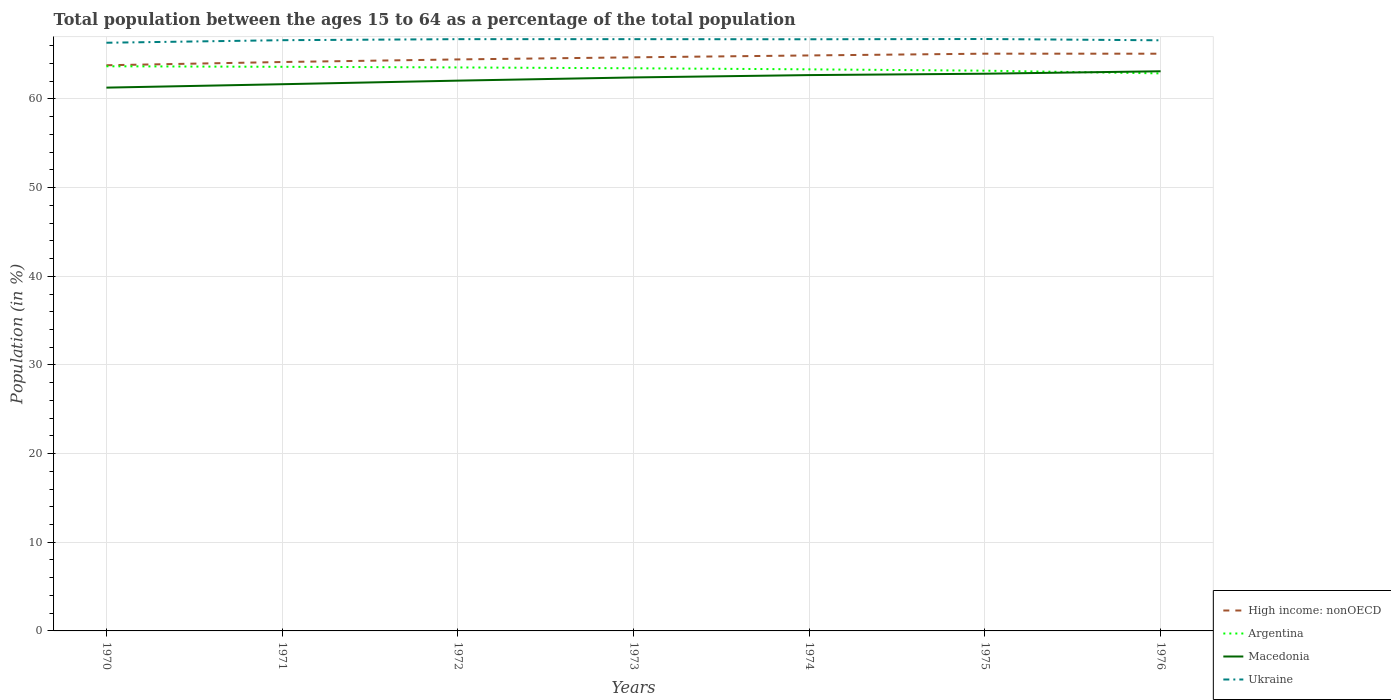Is the number of lines equal to the number of legend labels?
Your response must be concise. Yes. Across all years, what is the maximum percentage of the population ages 15 to 64 in Ukraine?
Provide a succinct answer. 66.34. In which year was the percentage of the population ages 15 to 64 in Argentina maximum?
Your answer should be very brief. 1976. What is the total percentage of the population ages 15 to 64 in Macedonia in the graph?
Provide a succinct answer. -0.63. What is the difference between the highest and the second highest percentage of the population ages 15 to 64 in Argentina?
Offer a very short reply. 0.8. How many years are there in the graph?
Keep it short and to the point. 7. Does the graph contain any zero values?
Offer a very short reply. No. How many legend labels are there?
Your answer should be very brief. 4. How are the legend labels stacked?
Provide a succinct answer. Vertical. What is the title of the graph?
Your answer should be very brief. Total population between the ages 15 to 64 as a percentage of the total population. Does "French Polynesia" appear as one of the legend labels in the graph?
Offer a very short reply. No. What is the label or title of the X-axis?
Provide a short and direct response. Years. What is the label or title of the Y-axis?
Offer a terse response. Population (in %). What is the Population (in %) in High income: nonOECD in 1970?
Offer a terse response. 63.8. What is the Population (in %) of Argentina in 1970?
Your response must be concise. 63.69. What is the Population (in %) in Macedonia in 1970?
Make the answer very short. 61.28. What is the Population (in %) of Ukraine in 1970?
Your answer should be very brief. 66.34. What is the Population (in %) in High income: nonOECD in 1971?
Your answer should be compact. 64.17. What is the Population (in %) of Argentina in 1971?
Your answer should be compact. 63.63. What is the Population (in %) of Macedonia in 1971?
Provide a succinct answer. 61.66. What is the Population (in %) in Ukraine in 1971?
Offer a very short reply. 66.63. What is the Population (in %) in High income: nonOECD in 1972?
Offer a very short reply. 64.46. What is the Population (in %) of Argentina in 1972?
Your answer should be compact. 63.55. What is the Population (in %) of Macedonia in 1972?
Your response must be concise. 62.07. What is the Population (in %) in Ukraine in 1972?
Your response must be concise. 66.74. What is the Population (in %) of High income: nonOECD in 1973?
Make the answer very short. 64.69. What is the Population (in %) of Argentina in 1973?
Ensure brevity in your answer.  63.46. What is the Population (in %) in Macedonia in 1973?
Ensure brevity in your answer.  62.43. What is the Population (in %) of Ukraine in 1973?
Keep it short and to the point. 66.74. What is the Population (in %) in High income: nonOECD in 1974?
Give a very brief answer. 64.91. What is the Population (in %) of Argentina in 1974?
Make the answer very short. 63.34. What is the Population (in %) in Macedonia in 1974?
Give a very brief answer. 62.69. What is the Population (in %) of Ukraine in 1974?
Make the answer very short. 66.73. What is the Population (in %) of High income: nonOECD in 1975?
Your answer should be very brief. 65.11. What is the Population (in %) in Argentina in 1975?
Make the answer very short. 63.19. What is the Population (in %) in Macedonia in 1975?
Provide a succinct answer. 62.85. What is the Population (in %) of Ukraine in 1975?
Make the answer very short. 66.76. What is the Population (in %) of High income: nonOECD in 1976?
Ensure brevity in your answer.  65.1. What is the Population (in %) of Argentina in 1976?
Offer a terse response. 62.88. What is the Population (in %) in Macedonia in 1976?
Ensure brevity in your answer.  63.12. What is the Population (in %) of Ukraine in 1976?
Provide a short and direct response. 66.62. Across all years, what is the maximum Population (in %) of High income: nonOECD?
Your answer should be very brief. 65.11. Across all years, what is the maximum Population (in %) of Argentina?
Keep it short and to the point. 63.69. Across all years, what is the maximum Population (in %) in Macedonia?
Give a very brief answer. 63.12. Across all years, what is the maximum Population (in %) of Ukraine?
Offer a terse response. 66.76. Across all years, what is the minimum Population (in %) of High income: nonOECD?
Ensure brevity in your answer.  63.8. Across all years, what is the minimum Population (in %) in Argentina?
Give a very brief answer. 62.88. Across all years, what is the minimum Population (in %) in Macedonia?
Offer a very short reply. 61.28. Across all years, what is the minimum Population (in %) of Ukraine?
Ensure brevity in your answer.  66.34. What is the total Population (in %) of High income: nonOECD in the graph?
Keep it short and to the point. 452.24. What is the total Population (in %) of Argentina in the graph?
Your answer should be very brief. 443.74. What is the total Population (in %) in Macedonia in the graph?
Your response must be concise. 436.09. What is the total Population (in %) in Ukraine in the graph?
Keep it short and to the point. 466.57. What is the difference between the Population (in %) in High income: nonOECD in 1970 and that in 1971?
Make the answer very short. -0.37. What is the difference between the Population (in %) of Argentina in 1970 and that in 1971?
Your response must be concise. 0.06. What is the difference between the Population (in %) of Macedonia in 1970 and that in 1971?
Your answer should be very brief. -0.38. What is the difference between the Population (in %) of Ukraine in 1970 and that in 1971?
Your answer should be compact. -0.29. What is the difference between the Population (in %) of High income: nonOECD in 1970 and that in 1972?
Provide a succinct answer. -0.66. What is the difference between the Population (in %) of Argentina in 1970 and that in 1972?
Offer a terse response. 0.13. What is the difference between the Population (in %) in Macedonia in 1970 and that in 1972?
Provide a short and direct response. -0.79. What is the difference between the Population (in %) in Ukraine in 1970 and that in 1972?
Provide a succinct answer. -0.4. What is the difference between the Population (in %) of High income: nonOECD in 1970 and that in 1973?
Make the answer very short. -0.89. What is the difference between the Population (in %) in Argentina in 1970 and that in 1973?
Ensure brevity in your answer.  0.23. What is the difference between the Population (in %) of Macedonia in 1970 and that in 1973?
Offer a terse response. -1.15. What is the difference between the Population (in %) of Ukraine in 1970 and that in 1973?
Provide a short and direct response. -0.4. What is the difference between the Population (in %) in High income: nonOECD in 1970 and that in 1974?
Provide a short and direct response. -1.11. What is the difference between the Population (in %) of Argentina in 1970 and that in 1974?
Your answer should be compact. 0.34. What is the difference between the Population (in %) in Macedonia in 1970 and that in 1974?
Provide a short and direct response. -1.41. What is the difference between the Population (in %) of Ukraine in 1970 and that in 1974?
Your answer should be very brief. -0.39. What is the difference between the Population (in %) of High income: nonOECD in 1970 and that in 1975?
Offer a very short reply. -1.31. What is the difference between the Population (in %) of Argentina in 1970 and that in 1975?
Keep it short and to the point. 0.5. What is the difference between the Population (in %) in Macedonia in 1970 and that in 1975?
Ensure brevity in your answer.  -1.57. What is the difference between the Population (in %) of Ukraine in 1970 and that in 1975?
Make the answer very short. -0.42. What is the difference between the Population (in %) in High income: nonOECD in 1970 and that in 1976?
Ensure brevity in your answer.  -1.3. What is the difference between the Population (in %) of Argentina in 1970 and that in 1976?
Your answer should be compact. 0.8. What is the difference between the Population (in %) of Macedonia in 1970 and that in 1976?
Offer a terse response. -1.85. What is the difference between the Population (in %) of Ukraine in 1970 and that in 1976?
Give a very brief answer. -0.28. What is the difference between the Population (in %) in High income: nonOECD in 1971 and that in 1972?
Your response must be concise. -0.29. What is the difference between the Population (in %) of Argentina in 1971 and that in 1972?
Provide a succinct answer. 0.07. What is the difference between the Population (in %) of Macedonia in 1971 and that in 1972?
Provide a succinct answer. -0.4. What is the difference between the Population (in %) in Ukraine in 1971 and that in 1972?
Offer a terse response. -0.12. What is the difference between the Population (in %) of High income: nonOECD in 1971 and that in 1973?
Make the answer very short. -0.53. What is the difference between the Population (in %) of Argentina in 1971 and that in 1973?
Your answer should be compact. 0.17. What is the difference between the Population (in %) in Macedonia in 1971 and that in 1973?
Offer a very short reply. -0.77. What is the difference between the Population (in %) of Ukraine in 1971 and that in 1973?
Your response must be concise. -0.12. What is the difference between the Population (in %) in High income: nonOECD in 1971 and that in 1974?
Provide a short and direct response. -0.74. What is the difference between the Population (in %) in Argentina in 1971 and that in 1974?
Your response must be concise. 0.29. What is the difference between the Population (in %) in Macedonia in 1971 and that in 1974?
Provide a succinct answer. -1.03. What is the difference between the Population (in %) in Ukraine in 1971 and that in 1974?
Your answer should be very brief. -0.1. What is the difference between the Population (in %) of High income: nonOECD in 1971 and that in 1975?
Keep it short and to the point. -0.94. What is the difference between the Population (in %) of Argentina in 1971 and that in 1975?
Your answer should be compact. 0.44. What is the difference between the Population (in %) in Macedonia in 1971 and that in 1975?
Provide a short and direct response. -1.19. What is the difference between the Population (in %) of Ukraine in 1971 and that in 1975?
Your answer should be compact. -0.13. What is the difference between the Population (in %) in High income: nonOECD in 1971 and that in 1976?
Offer a terse response. -0.94. What is the difference between the Population (in %) of Argentina in 1971 and that in 1976?
Make the answer very short. 0.75. What is the difference between the Population (in %) in Macedonia in 1971 and that in 1976?
Provide a succinct answer. -1.46. What is the difference between the Population (in %) of Ukraine in 1971 and that in 1976?
Keep it short and to the point. 0.01. What is the difference between the Population (in %) of High income: nonOECD in 1972 and that in 1973?
Your answer should be compact. -0.24. What is the difference between the Population (in %) of Argentina in 1972 and that in 1973?
Provide a succinct answer. 0.09. What is the difference between the Population (in %) of Macedonia in 1972 and that in 1973?
Ensure brevity in your answer.  -0.36. What is the difference between the Population (in %) of Ukraine in 1972 and that in 1973?
Offer a terse response. -0. What is the difference between the Population (in %) of High income: nonOECD in 1972 and that in 1974?
Give a very brief answer. -0.45. What is the difference between the Population (in %) of Argentina in 1972 and that in 1974?
Your answer should be compact. 0.21. What is the difference between the Population (in %) in Macedonia in 1972 and that in 1974?
Provide a succinct answer. -0.63. What is the difference between the Population (in %) in Ukraine in 1972 and that in 1974?
Offer a terse response. 0.01. What is the difference between the Population (in %) in High income: nonOECD in 1972 and that in 1975?
Provide a succinct answer. -0.65. What is the difference between the Population (in %) in Argentina in 1972 and that in 1975?
Ensure brevity in your answer.  0.36. What is the difference between the Population (in %) in Macedonia in 1972 and that in 1975?
Your answer should be compact. -0.78. What is the difference between the Population (in %) in Ukraine in 1972 and that in 1975?
Offer a terse response. -0.02. What is the difference between the Population (in %) of High income: nonOECD in 1972 and that in 1976?
Ensure brevity in your answer.  -0.65. What is the difference between the Population (in %) of Argentina in 1972 and that in 1976?
Ensure brevity in your answer.  0.67. What is the difference between the Population (in %) of Macedonia in 1972 and that in 1976?
Offer a terse response. -1.06. What is the difference between the Population (in %) of Ukraine in 1972 and that in 1976?
Ensure brevity in your answer.  0.13. What is the difference between the Population (in %) of High income: nonOECD in 1973 and that in 1974?
Your answer should be very brief. -0.21. What is the difference between the Population (in %) in Argentina in 1973 and that in 1974?
Provide a short and direct response. 0.12. What is the difference between the Population (in %) in Macedonia in 1973 and that in 1974?
Offer a very short reply. -0.26. What is the difference between the Population (in %) in Ukraine in 1973 and that in 1974?
Offer a terse response. 0.01. What is the difference between the Population (in %) of High income: nonOECD in 1973 and that in 1975?
Your answer should be very brief. -0.41. What is the difference between the Population (in %) in Argentina in 1973 and that in 1975?
Make the answer very short. 0.27. What is the difference between the Population (in %) of Macedonia in 1973 and that in 1975?
Your answer should be very brief. -0.42. What is the difference between the Population (in %) of Ukraine in 1973 and that in 1975?
Offer a very short reply. -0.02. What is the difference between the Population (in %) of High income: nonOECD in 1973 and that in 1976?
Your response must be concise. -0.41. What is the difference between the Population (in %) of Argentina in 1973 and that in 1976?
Provide a succinct answer. 0.58. What is the difference between the Population (in %) in Macedonia in 1973 and that in 1976?
Keep it short and to the point. -0.7. What is the difference between the Population (in %) in Ukraine in 1973 and that in 1976?
Your answer should be compact. 0.13. What is the difference between the Population (in %) of High income: nonOECD in 1974 and that in 1975?
Your response must be concise. -0.2. What is the difference between the Population (in %) in Argentina in 1974 and that in 1975?
Offer a terse response. 0.15. What is the difference between the Population (in %) of Macedonia in 1974 and that in 1975?
Offer a very short reply. -0.16. What is the difference between the Population (in %) in Ukraine in 1974 and that in 1975?
Your answer should be very brief. -0.03. What is the difference between the Population (in %) in High income: nonOECD in 1974 and that in 1976?
Your answer should be very brief. -0.2. What is the difference between the Population (in %) in Argentina in 1974 and that in 1976?
Offer a terse response. 0.46. What is the difference between the Population (in %) of Macedonia in 1974 and that in 1976?
Make the answer very short. -0.43. What is the difference between the Population (in %) of Ukraine in 1974 and that in 1976?
Offer a very short reply. 0.12. What is the difference between the Population (in %) in High income: nonOECD in 1975 and that in 1976?
Ensure brevity in your answer.  0. What is the difference between the Population (in %) in Argentina in 1975 and that in 1976?
Provide a succinct answer. 0.31. What is the difference between the Population (in %) of Macedonia in 1975 and that in 1976?
Your answer should be compact. -0.28. What is the difference between the Population (in %) of Ukraine in 1975 and that in 1976?
Provide a succinct answer. 0.15. What is the difference between the Population (in %) in High income: nonOECD in 1970 and the Population (in %) in Argentina in 1971?
Offer a very short reply. 0.17. What is the difference between the Population (in %) in High income: nonOECD in 1970 and the Population (in %) in Macedonia in 1971?
Give a very brief answer. 2.14. What is the difference between the Population (in %) in High income: nonOECD in 1970 and the Population (in %) in Ukraine in 1971?
Your answer should be compact. -2.83. What is the difference between the Population (in %) of Argentina in 1970 and the Population (in %) of Macedonia in 1971?
Keep it short and to the point. 2.02. What is the difference between the Population (in %) of Argentina in 1970 and the Population (in %) of Ukraine in 1971?
Provide a succinct answer. -2.94. What is the difference between the Population (in %) in Macedonia in 1970 and the Population (in %) in Ukraine in 1971?
Your response must be concise. -5.35. What is the difference between the Population (in %) in High income: nonOECD in 1970 and the Population (in %) in Argentina in 1972?
Your answer should be very brief. 0.25. What is the difference between the Population (in %) in High income: nonOECD in 1970 and the Population (in %) in Macedonia in 1972?
Provide a short and direct response. 1.74. What is the difference between the Population (in %) of High income: nonOECD in 1970 and the Population (in %) of Ukraine in 1972?
Your response must be concise. -2.94. What is the difference between the Population (in %) of Argentina in 1970 and the Population (in %) of Macedonia in 1972?
Give a very brief answer. 1.62. What is the difference between the Population (in %) of Argentina in 1970 and the Population (in %) of Ukraine in 1972?
Provide a short and direct response. -3.06. What is the difference between the Population (in %) of Macedonia in 1970 and the Population (in %) of Ukraine in 1972?
Offer a very short reply. -5.47. What is the difference between the Population (in %) in High income: nonOECD in 1970 and the Population (in %) in Argentina in 1973?
Ensure brevity in your answer.  0.34. What is the difference between the Population (in %) in High income: nonOECD in 1970 and the Population (in %) in Macedonia in 1973?
Provide a short and direct response. 1.37. What is the difference between the Population (in %) of High income: nonOECD in 1970 and the Population (in %) of Ukraine in 1973?
Your answer should be compact. -2.94. What is the difference between the Population (in %) in Argentina in 1970 and the Population (in %) in Macedonia in 1973?
Your answer should be very brief. 1.26. What is the difference between the Population (in %) of Argentina in 1970 and the Population (in %) of Ukraine in 1973?
Offer a terse response. -3.06. What is the difference between the Population (in %) in Macedonia in 1970 and the Population (in %) in Ukraine in 1973?
Offer a terse response. -5.47. What is the difference between the Population (in %) in High income: nonOECD in 1970 and the Population (in %) in Argentina in 1974?
Ensure brevity in your answer.  0.46. What is the difference between the Population (in %) of High income: nonOECD in 1970 and the Population (in %) of Macedonia in 1974?
Offer a terse response. 1.11. What is the difference between the Population (in %) in High income: nonOECD in 1970 and the Population (in %) in Ukraine in 1974?
Provide a short and direct response. -2.93. What is the difference between the Population (in %) in Argentina in 1970 and the Population (in %) in Ukraine in 1974?
Provide a succinct answer. -3.05. What is the difference between the Population (in %) of Macedonia in 1970 and the Population (in %) of Ukraine in 1974?
Ensure brevity in your answer.  -5.45. What is the difference between the Population (in %) in High income: nonOECD in 1970 and the Population (in %) in Argentina in 1975?
Make the answer very short. 0.61. What is the difference between the Population (in %) of High income: nonOECD in 1970 and the Population (in %) of Macedonia in 1975?
Offer a very short reply. 0.95. What is the difference between the Population (in %) of High income: nonOECD in 1970 and the Population (in %) of Ukraine in 1975?
Offer a very short reply. -2.96. What is the difference between the Population (in %) in Argentina in 1970 and the Population (in %) in Macedonia in 1975?
Give a very brief answer. 0.84. What is the difference between the Population (in %) of Argentina in 1970 and the Population (in %) of Ukraine in 1975?
Provide a succinct answer. -3.08. What is the difference between the Population (in %) of Macedonia in 1970 and the Population (in %) of Ukraine in 1975?
Your answer should be very brief. -5.48. What is the difference between the Population (in %) of High income: nonOECD in 1970 and the Population (in %) of Argentina in 1976?
Provide a short and direct response. 0.92. What is the difference between the Population (in %) of High income: nonOECD in 1970 and the Population (in %) of Macedonia in 1976?
Keep it short and to the point. 0.68. What is the difference between the Population (in %) in High income: nonOECD in 1970 and the Population (in %) in Ukraine in 1976?
Ensure brevity in your answer.  -2.82. What is the difference between the Population (in %) in Argentina in 1970 and the Population (in %) in Macedonia in 1976?
Provide a succinct answer. 0.56. What is the difference between the Population (in %) of Argentina in 1970 and the Population (in %) of Ukraine in 1976?
Give a very brief answer. -2.93. What is the difference between the Population (in %) in Macedonia in 1970 and the Population (in %) in Ukraine in 1976?
Provide a short and direct response. -5.34. What is the difference between the Population (in %) of High income: nonOECD in 1971 and the Population (in %) of Argentina in 1972?
Ensure brevity in your answer.  0.61. What is the difference between the Population (in %) of High income: nonOECD in 1971 and the Population (in %) of Macedonia in 1972?
Ensure brevity in your answer.  2.1. What is the difference between the Population (in %) of High income: nonOECD in 1971 and the Population (in %) of Ukraine in 1972?
Provide a short and direct response. -2.58. What is the difference between the Population (in %) in Argentina in 1971 and the Population (in %) in Macedonia in 1972?
Ensure brevity in your answer.  1.56. What is the difference between the Population (in %) in Argentina in 1971 and the Population (in %) in Ukraine in 1972?
Provide a short and direct response. -3.12. What is the difference between the Population (in %) in Macedonia in 1971 and the Population (in %) in Ukraine in 1972?
Make the answer very short. -5.08. What is the difference between the Population (in %) in High income: nonOECD in 1971 and the Population (in %) in Argentina in 1973?
Offer a very short reply. 0.71. What is the difference between the Population (in %) of High income: nonOECD in 1971 and the Population (in %) of Macedonia in 1973?
Offer a very short reply. 1.74. What is the difference between the Population (in %) of High income: nonOECD in 1971 and the Population (in %) of Ukraine in 1973?
Ensure brevity in your answer.  -2.58. What is the difference between the Population (in %) in Argentina in 1971 and the Population (in %) in Macedonia in 1973?
Keep it short and to the point. 1.2. What is the difference between the Population (in %) of Argentina in 1971 and the Population (in %) of Ukraine in 1973?
Ensure brevity in your answer.  -3.12. What is the difference between the Population (in %) of Macedonia in 1971 and the Population (in %) of Ukraine in 1973?
Give a very brief answer. -5.08. What is the difference between the Population (in %) in High income: nonOECD in 1971 and the Population (in %) in Argentina in 1974?
Give a very brief answer. 0.83. What is the difference between the Population (in %) of High income: nonOECD in 1971 and the Population (in %) of Macedonia in 1974?
Your answer should be compact. 1.48. What is the difference between the Population (in %) in High income: nonOECD in 1971 and the Population (in %) in Ukraine in 1974?
Offer a very short reply. -2.57. What is the difference between the Population (in %) in Argentina in 1971 and the Population (in %) in Ukraine in 1974?
Your answer should be very brief. -3.1. What is the difference between the Population (in %) in Macedonia in 1971 and the Population (in %) in Ukraine in 1974?
Your answer should be very brief. -5.07. What is the difference between the Population (in %) of High income: nonOECD in 1971 and the Population (in %) of Argentina in 1975?
Offer a terse response. 0.98. What is the difference between the Population (in %) of High income: nonOECD in 1971 and the Population (in %) of Macedonia in 1975?
Your answer should be very brief. 1.32. What is the difference between the Population (in %) in High income: nonOECD in 1971 and the Population (in %) in Ukraine in 1975?
Your response must be concise. -2.59. What is the difference between the Population (in %) in Argentina in 1971 and the Population (in %) in Macedonia in 1975?
Keep it short and to the point. 0.78. What is the difference between the Population (in %) in Argentina in 1971 and the Population (in %) in Ukraine in 1975?
Ensure brevity in your answer.  -3.13. What is the difference between the Population (in %) in High income: nonOECD in 1971 and the Population (in %) in Argentina in 1976?
Give a very brief answer. 1.28. What is the difference between the Population (in %) in High income: nonOECD in 1971 and the Population (in %) in Macedonia in 1976?
Provide a short and direct response. 1.04. What is the difference between the Population (in %) in High income: nonOECD in 1971 and the Population (in %) in Ukraine in 1976?
Ensure brevity in your answer.  -2.45. What is the difference between the Population (in %) of Argentina in 1971 and the Population (in %) of Macedonia in 1976?
Keep it short and to the point. 0.51. What is the difference between the Population (in %) of Argentina in 1971 and the Population (in %) of Ukraine in 1976?
Keep it short and to the point. -2.99. What is the difference between the Population (in %) in Macedonia in 1971 and the Population (in %) in Ukraine in 1976?
Keep it short and to the point. -4.95. What is the difference between the Population (in %) of High income: nonOECD in 1972 and the Population (in %) of Macedonia in 1973?
Ensure brevity in your answer.  2.03. What is the difference between the Population (in %) of High income: nonOECD in 1972 and the Population (in %) of Ukraine in 1973?
Your answer should be very brief. -2.29. What is the difference between the Population (in %) of Argentina in 1972 and the Population (in %) of Macedonia in 1973?
Your response must be concise. 1.13. What is the difference between the Population (in %) in Argentina in 1972 and the Population (in %) in Ukraine in 1973?
Your answer should be compact. -3.19. What is the difference between the Population (in %) of Macedonia in 1972 and the Population (in %) of Ukraine in 1973?
Your answer should be compact. -4.68. What is the difference between the Population (in %) of High income: nonOECD in 1972 and the Population (in %) of Argentina in 1974?
Give a very brief answer. 1.12. What is the difference between the Population (in %) of High income: nonOECD in 1972 and the Population (in %) of Macedonia in 1974?
Offer a terse response. 1.77. What is the difference between the Population (in %) of High income: nonOECD in 1972 and the Population (in %) of Ukraine in 1974?
Provide a succinct answer. -2.27. What is the difference between the Population (in %) of Argentina in 1972 and the Population (in %) of Macedonia in 1974?
Give a very brief answer. 0.86. What is the difference between the Population (in %) of Argentina in 1972 and the Population (in %) of Ukraine in 1974?
Offer a very short reply. -3.18. What is the difference between the Population (in %) of Macedonia in 1972 and the Population (in %) of Ukraine in 1974?
Make the answer very short. -4.67. What is the difference between the Population (in %) in High income: nonOECD in 1972 and the Population (in %) in Argentina in 1975?
Offer a very short reply. 1.27. What is the difference between the Population (in %) in High income: nonOECD in 1972 and the Population (in %) in Macedonia in 1975?
Provide a short and direct response. 1.61. What is the difference between the Population (in %) in High income: nonOECD in 1972 and the Population (in %) in Ukraine in 1975?
Keep it short and to the point. -2.3. What is the difference between the Population (in %) in Argentina in 1972 and the Population (in %) in Macedonia in 1975?
Your answer should be very brief. 0.71. What is the difference between the Population (in %) of Argentina in 1972 and the Population (in %) of Ukraine in 1975?
Ensure brevity in your answer.  -3.21. What is the difference between the Population (in %) of Macedonia in 1972 and the Population (in %) of Ukraine in 1975?
Ensure brevity in your answer.  -4.7. What is the difference between the Population (in %) in High income: nonOECD in 1972 and the Population (in %) in Argentina in 1976?
Offer a terse response. 1.58. What is the difference between the Population (in %) in High income: nonOECD in 1972 and the Population (in %) in Macedonia in 1976?
Your answer should be very brief. 1.34. What is the difference between the Population (in %) in High income: nonOECD in 1972 and the Population (in %) in Ukraine in 1976?
Provide a succinct answer. -2.16. What is the difference between the Population (in %) of Argentina in 1972 and the Population (in %) of Macedonia in 1976?
Provide a short and direct response. 0.43. What is the difference between the Population (in %) in Argentina in 1972 and the Population (in %) in Ukraine in 1976?
Offer a very short reply. -3.06. What is the difference between the Population (in %) in Macedonia in 1972 and the Population (in %) in Ukraine in 1976?
Keep it short and to the point. -4.55. What is the difference between the Population (in %) of High income: nonOECD in 1973 and the Population (in %) of Argentina in 1974?
Keep it short and to the point. 1.35. What is the difference between the Population (in %) of High income: nonOECD in 1973 and the Population (in %) of Macedonia in 1974?
Give a very brief answer. 2. What is the difference between the Population (in %) of High income: nonOECD in 1973 and the Population (in %) of Ukraine in 1974?
Give a very brief answer. -2.04. What is the difference between the Population (in %) in Argentina in 1973 and the Population (in %) in Macedonia in 1974?
Offer a terse response. 0.77. What is the difference between the Population (in %) in Argentina in 1973 and the Population (in %) in Ukraine in 1974?
Give a very brief answer. -3.27. What is the difference between the Population (in %) of Macedonia in 1973 and the Population (in %) of Ukraine in 1974?
Keep it short and to the point. -4.31. What is the difference between the Population (in %) in High income: nonOECD in 1973 and the Population (in %) in Argentina in 1975?
Offer a very short reply. 1.51. What is the difference between the Population (in %) in High income: nonOECD in 1973 and the Population (in %) in Macedonia in 1975?
Offer a terse response. 1.85. What is the difference between the Population (in %) in High income: nonOECD in 1973 and the Population (in %) in Ukraine in 1975?
Your response must be concise. -2.07. What is the difference between the Population (in %) of Argentina in 1973 and the Population (in %) of Macedonia in 1975?
Give a very brief answer. 0.61. What is the difference between the Population (in %) of Argentina in 1973 and the Population (in %) of Ukraine in 1975?
Ensure brevity in your answer.  -3.3. What is the difference between the Population (in %) in Macedonia in 1973 and the Population (in %) in Ukraine in 1975?
Your answer should be compact. -4.33. What is the difference between the Population (in %) in High income: nonOECD in 1973 and the Population (in %) in Argentina in 1976?
Ensure brevity in your answer.  1.81. What is the difference between the Population (in %) of High income: nonOECD in 1973 and the Population (in %) of Macedonia in 1976?
Give a very brief answer. 1.57. What is the difference between the Population (in %) of High income: nonOECD in 1973 and the Population (in %) of Ukraine in 1976?
Offer a very short reply. -1.92. What is the difference between the Population (in %) of Argentina in 1973 and the Population (in %) of Macedonia in 1976?
Offer a very short reply. 0.34. What is the difference between the Population (in %) of Argentina in 1973 and the Population (in %) of Ukraine in 1976?
Make the answer very short. -3.16. What is the difference between the Population (in %) of Macedonia in 1973 and the Population (in %) of Ukraine in 1976?
Your response must be concise. -4.19. What is the difference between the Population (in %) in High income: nonOECD in 1974 and the Population (in %) in Argentina in 1975?
Keep it short and to the point. 1.72. What is the difference between the Population (in %) of High income: nonOECD in 1974 and the Population (in %) of Macedonia in 1975?
Offer a terse response. 2.06. What is the difference between the Population (in %) of High income: nonOECD in 1974 and the Population (in %) of Ukraine in 1975?
Offer a very short reply. -1.85. What is the difference between the Population (in %) in Argentina in 1974 and the Population (in %) in Macedonia in 1975?
Make the answer very short. 0.49. What is the difference between the Population (in %) of Argentina in 1974 and the Population (in %) of Ukraine in 1975?
Provide a succinct answer. -3.42. What is the difference between the Population (in %) of Macedonia in 1974 and the Population (in %) of Ukraine in 1975?
Provide a succinct answer. -4.07. What is the difference between the Population (in %) in High income: nonOECD in 1974 and the Population (in %) in Argentina in 1976?
Your answer should be very brief. 2.03. What is the difference between the Population (in %) in High income: nonOECD in 1974 and the Population (in %) in Macedonia in 1976?
Provide a succinct answer. 1.78. What is the difference between the Population (in %) of High income: nonOECD in 1974 and the Population (in %) of Ukraine in 1976?
Make the answer very short. -1.71. What is the difference between the Population (in %) in Argentina in 1974 and the Population (in %) in Macedonia in 1976?
Provide a succinct answer. 0.22. What is the difference between the Population (in %) of Argentina in 1974 and the Population (in %) of Ukraine in 1976?
Give a very brief answer. -3.27. What is the difference between the Population (in %) in Macedonia in 1974 and the Population (in %) in Ukraine in 1976?
Give a very brief answer. -3.92. What is the difference between the Population (in %) in High income: nonOECD in 1975 and the Population (in %) in Argentina in 1976?
Offer a very short reply. 2.22. What is the difference between the Population (in %) of High income: nonOECD in 1975 and the Population (in %) of Macedonia in 1976?
Provide a succinct answer. 1.98. What is the difference between the Population (in %) of High income: nonOECD in 1975 and the Population (in %) of Ukraine in 1976?
Ensure brevity in your answer.  -1.51. What is the difference between the Population (in %) in Argentina in 1975 and the Population (in %) in Macedonia in 1976?
Keep it short and to the point. 0.07. What is the difference between the Population (in %) of Argentina in 1975 and the Population (in %) of Ukraine in 1976?
Provide a succinct answer. -3.43. What is the difference between the Population (in %) in Macedonia in 1975 and the Population (in %) in Ukraine in 1976?
Your answer should be compact. -3.77. What is the average Population (in %) of High income: nonOECD per year?
Your answer should be very brief. 64.61. What is the average Population (in %) of Argentina per year?
Offer a very short reply. 63.39. What is the average Population (in %) of Macedonia per year?
Offer a terse response. 62.3. What is the average Population (in %) of Ukraine per year?
Ensure brevity in your answer.  66.65. In the year 1970, what is the difference between the Population (in %) of High income: nonOECD and Population (in %) of Argentina?
Provide a succinct answer. 0.11. In the year 1970, what is the difference between the Population (in %) in High income: nonOECD and Population (in %) in Macedonia?
Your answer should be compact. 2.52. In the year 1970, what is the difference between the Population (in %) of High income: nonOECD and Population (in %) of Ukraine?
Provide a short and direct response. -2.54. In the year 1970, what is the difference between the Population (in %) of Argentina and Population (in %) of Macedonia?
Make the answer very short. 2.41. In the year 1970, what is the difference between the Population (in %) of Argentina and Population (in %) of Ukraine?
Offer a very short reply. -2.65. In the year 1970, what is the difference between the Population (in %) in Macedonia and Population (in %) in Ukraine?
Provide a short and direct response. -5.06. In the year 1971, what is the difference between the Population (in %) in High income: nonOECD and Population (in %) in Argentina?
Your response must be concise. 0.54. In the year 1971, what is the difference between the Population (in %) of High income: nonOECD and Population (in %) of Macedonia?
Provide a short and direct response. 2.51. In the year 1971, what is the difference between the Population (in %) of High income: nonOECD and Population (in %) of Ukraine?
Make the answer very short. -2.46. In the year 1971, what is the difference between the Population (in %) of Argentina and Population (in %) of Macedonia?
Give a very brief answer. 1.97. In the year 1971, what is the difference between the Population (in %) of Argentina and Population (in %) of Ukraine?
Offer a very short reply. -3. In the year 1971, what is the difference between the Population (in %) in Macedonia and Population (in %) in Ukraine?
Provide a short and direct response. -4.97. In the year 1972, what is the difference between the Population (in %) of High income: nonOECD and Population (in %) of Argentina?
Offer a very short reply. 0.9. In the year 1972, what is the difference between the Population (in %) of High income: nonOECD and Population (in %) of Macedonia?
Offer a terse response. 2.39. In the year 1972, what is the difference between the Population (in %) of High income: nonOECD and Population (in %) of Ukraine?
Your answer should be compact. -2.29. In the year 1972, what is the difference between the Population (in %) of Argentina and Population (in %) of Macedonia?
Your answer should be compact. 1.49. In the year 1972, what is the difference between the Population (in %) in Argentina and Population (in %) in Ukraine?
Offer a terse response. -3.19. In the year 1972, what is the difference between the Population (in %) in Macedonia and Population (in %) in Ukraine?
Offer a very short reply. -4.68. In the year 1973, what is the difference between the Population (in %) of High income: nonOECD and Population (in %) of Argentina?
Your response must be concise. 1.23. In the year 1973, what is the difference between the Population (in %) of High income: nonOECD and Population (in %) of Macedonia?
Provide a short and direct response. 2.27. In the year 1973, what is the difference between the Population (in %) in High income: nonOECD and Population (in %) in Ukraine?
Give a very brief answer. -2.05. In the year 1973, what is the difference between the Population (in %) in Argentina and Population (in %) in Macedonia?
Your response must be concise. 1.03. In the year 1973, what is the difference between the Population (in %) in Argentina and Population (in %) in Ukraine?
Ensure brevity in your answer.  -3.28. In the year 1973, what is the difference between the Population (in %) in Macedonia and Population (in %) in Ukraine?
Provide a succinct answer. -4.32. In the year 1974, what is the difference between the Population (in %) of High income: nonOECD and Population (in %) of Argentina?
Your answer should be compact. 1.57. In the year 1974, what is the difference between the Population (in %) of High income: nonOECD and Population (in %) of Macedonia?
Offer a very short reply. 2.22. In the year 1974, what is the difference between the Population (in %) in High income: nonOECD and Population (in %) in Ukraine?
Make the answer very short. -1.82. In the year 1974, what is the difference between the Population (in %) in Argentina and Population (in %) in Macedonia?
Your response must be concise. 0.65. In the year 1974, what is the difference between the Population (in %) of Argentina and Population (in %) of Ukraine?
Provide a succinct answer. -3.39. In the year 1974, what is the difference between the Population (in %) in Macedonia and Population (in %) in Ukraine?
Your response must be concise. -4.04. In the year 1975, what is the difference between the Population (in %) of High income: nonOECD and Population (in %) of Argentina?
Keep it short and to the point. 1.92. In the year 1975, what is the difference between the Population (in %) of High income: nonOECD and Population (in %) of Macedonia?
Provide a succinct answer. 2.26. In the year 1975, what is the difference between the Population (in %) in High income: nonOECD and Population (in %) in Ukraine?
Keep it short and to the point. -1.66. In the year 1975, what is the difference between the Population (in %) in Argentina and Population (in %) in Macedonia?
Ensure brevity in your answer.  0.34. In the year 1975, what is the difference between the Population (in %) in Argentina and Population (in %) in Ukraine?
Make the answer very short. -3.57. In the year 1975, what is the difference between the Population (in %) of Macedonia and Population (in %) of Ukraine?
Keep it short and to the point. -3.91. In the year 1976, what is the difference between the Population (in %) in High income: nonOECD and Population (in %) in Argentina?
Make the answer very short. 2.22. In the year 1976, what is the difference between the Population (in %) in High income: nonOECD and Population (in %) in Macedonia?
Your response must be concise. 1.98. In the year 1976, what is the difference between the Population (in %) of High income: nonOECD and Population (in %) of Ukraine?
Provide a succinct answer. -1.51. In the year 1976, what is the difference between the Population (in %) in Argentina and Population (in %) in Macedonia?
Your response must be concise. -0.24. In the year 1976, what is the difference between the Population (in %) of Argentina and Population (in %) of Ukraine?
Give a very brief answer. -3.73. In the year 1976, what is the difference between the Population (in %) of Macedonia and Population (in %) of Ukraine?
Make the answer very short. -3.49. What is the ratio of the Population (in %) of High income: nonOECD in 1970 to that in 1971?
Provide a succinct answer. 0.99. What is the ratio of the Population (in %) in Argentina in 1970 to that in 1971?
Your answer should be compact. 1. What is the ratio of the Population (in %) of High income: nonOECD in 1970 to that in 1972?
Offer a very short reply. 0.99. What is the ratio of the Population (in %) of Macedonia in 1970 to that in 1972?
Ensure brevity in your answer.  0.99. What is the ratio of the Population (in %) of Ukraine in 1970 to that in 1972?
Give a very brief answer. 0.99. What is the ratio of the Population (in %) of High income: nonOECD in 1970 to that in 1973?
Provide a short and direct response. 0.99. What is the ratio of the Population (in %) of Argentina in 1970 to that in 1973?
Keep it short and to the point. 1. What is the ratio of the Population (in %) in Macedonia in 1970 to that in 1973?
Provide a succinct answer. 0.98. What is the ratio of the Population (in %) in Ukraine in 1970 to that in 1973?
Your answer should be compact. 0.99. What is the ratio of the Population (in %) of High income: nonOECD in 1970 to that in 1974?
Offer a very short reply. 0.98. What is the ratio of the Population (in %) of Argentina in 1970 to that in 1974?
Your response must be concise. 1.01. What is the ratio of the Population (in %) in Macedonia in 1970 to that in 1974?
Ensure brevity in your answer.  0.98. What is the ratio of the Population (in %) in High income: nonOECD in 1970 to that in 1975?
Ensure brevity in your answer.  0.98. What is the ratio of the Population (in %) of Argentina in 1970 to that in 1975?
Your answer should be compact. 1.01. What is the ratio of the Population (in %) in Argentina in 1970 to that in 1976?
Offer a very short reply. 1.01. What is the ratio of the Population (in %) of Macedonia in 1970 to that in 1976?
Provide a short and direct response. 0.97. What is the ratio of the Population (in %) in Macedonia in 1971 to that in 1972?
Keep it short and to the point. 0.99. What is the ratio of the Population (in %) of Argentina in 1971 to that in 1973?
Offer a very short reply. 1. What is the ratio of the Population (in %) of Ukraine in 1971 to that in 1973?
Ensure brevity in your answer.  1. What is the ratio of the Population (in %) in Argentina in 1971 to that in 1974?
Offer a very short reply. 1. What is the ratio of the Population (in %) in Macedonia in 1971 to that in 1974?
Offer a very short reply. 0.98. What is the ratio of the Population (in %) of Ukraine in 1971 to that in 1974?
Provide a short and direct response. 1. What is the ratio of the Population (in %) in High income: nonOECD in 1971 to that in 1975?
Provide a short and direct response. 0.99. What is the ratio of the Population (in %) in Argentina in 1971 to that in 1975?
Keep it short and to the point. 1.01. What is the ratio of the Population (in %) of Macedonia in 1971 to that in 1975?
Your answer should be very brief. 0.98. What is the ratio of the Population (in %) of High income: nonOECD in 1971 to that in 1976?
Provide a short and direct response. 0.99. What is the ratio of the Population (in %) in Argentina in 1971 to that in 1976?
Make the answer very short. 1.01. What is the ratio of the Population (in %) of Macedonia in 1971 to that in 1976?
Your response must be concise. 0.98. What is the ratio of the Population (in %) in Ukraine in 1971 to that in 1976?
Keep it short and to the point. 1. What is the ratio of the Population (in %) of High income: nonOECD in 1972 to that in 1973?
Your response must be concise. 1. What is the ratio of the Population (in %) in Argentina in 1972 to that in 1973?
Your response must be concise. 1. What is the ratio of the Population (in %) of Ukraine in 1972 to that in 1973?
Keep it short and to the point. 1. What is the ratio of the Population (in %) in High income: nonOECD in 1972 to that in 1974?
Give a very brief answer. 0.99. What is the ratio of the Population (in %) of Argentina in 1972 to that in 1974?
Give a very brief answer. 1. What is the ratio of the Population (in %) of High income: nonOECD in 1972 to that in 1975?
Your answer should be very brief. 0.99. What is the ratio of the Population (in %) in Argentina in 1972 to that in 1975?
Offer a terse response. 1.01. What is the ratio of the Population (in %) of Macedonia in 1972 to that in 1975?
Provide a succinct answer. 0.99. What is the ratio of the Population (in %) in Ukraine in 1972 to that in 1975?
Provide a short and direct response. 1. What is the ratio of the Population (in %) in High income: nonOECD in 1972 to that in 1976?
Your answer should be compact. 0.99. What is the ratio of the Population (in %) of Argentina in 1972 to that in 1976?
Ensure brevity in your answer.  1.01. What is the ratio of the Population (in %) in Macedonia in 1972 to that in 1976?
Keep it short and to the point. 0.98. What is the ratio of the Population (in %) in Ukraine in 1972 to that in 1976?
Ensure brevity in your answer.  1. What is the ratio of the Population (in %) of Argentina in 1973 to that in 1974?
Offer a terse response. 1. What is the ratio of the Population (in %) in Ukraine in 1973 to that in 1974?
Provide a short and direct response. 1. What is the ratio of the Population (in %) of High income: nonOECD in 1973 to that in 1975?
Your answer should be very brief. 0.99. What is the ratio of the Population (in %) of Argentina in 1973 to that in 1975?
Your answer should be compact. 1. What is the ratio of the Population (in %) of Macedonia in 1973 to that in 1975?
Your answer should be compact. 0.99. What is the ratio of the Population (in %) in Ukraine in 1973 to that in 1975?
Ensure brevity in your answer.  1. What is the ratio of the Population (in %) in High income: nonOECD in 1973 to that in 1976?
Give a very brief answer. 0.99. What is the ratio of the Population (in %) in Argentina in 1973 to that in 1976?
Provide a short and direct response. 1.01. What is the ratio of the Population (in %) of High income: nonOECD in 1974 to that in 1975?
Give a very brief answer. 1. What is the ratio of the Population (in %) of Macedonia in 1974 to that in 1975?
Give a very brief answer. 1. What is the ratio of the Population (in %) in High income: nonOECD in 1974 to that in 1976?
Your answer should be very brief. 1. What is the ratio of the Population (in %) in Argentina in 1974 to that in 1976?
Offer a very short reply. 1.01. What is the ratio of the Population (in %) of High income: nonOECD in 1975 to that in 1976?
Offer a very short reply. 1. What is the ratio of the Population (in %) in Argentina in 1975 to that in 1976?
Give a very brief answer. 1. What is the ratio of the Population (in %) of Macedonia in 1975 to that in 1976?
Offer a terse response. 1. What is the ratio of the Population (in %) in Ukraine in 1975 to that in 1976?
Your response must be concise. 1. What is the difference between the highest and the second highest Population (in %) of High income: nonOECD?
Provide a succinct answer. 0. What is the difference between the highest and the second highest Population (in %) in Argentina?
Keep it short and to the point. 0.06. What is the difference between the highest and the second highest Population (in %) of Macedonia?
Offer a terse response. 0.28. What is the difference between the highest and the second highest Population (in %) in Ukraine?
Provide a short and direct response. 0.02. What is the difference between the highest and the lowest Population (in %) in High income: nonOECD?
Provide a short and direct response. 1.31. What is the difference between the highest and the lowest Population (in %) of Argentina?
Give a very brief answer. 0.8. What is the difference between the highest and the lowest Population (in %) in Macedonia?
Ensure brevity in your answer.  1.85. What is the difference between the highest and the lowest Population (in %) in Ukraine?
Your answer should be very brief. 0.42. 